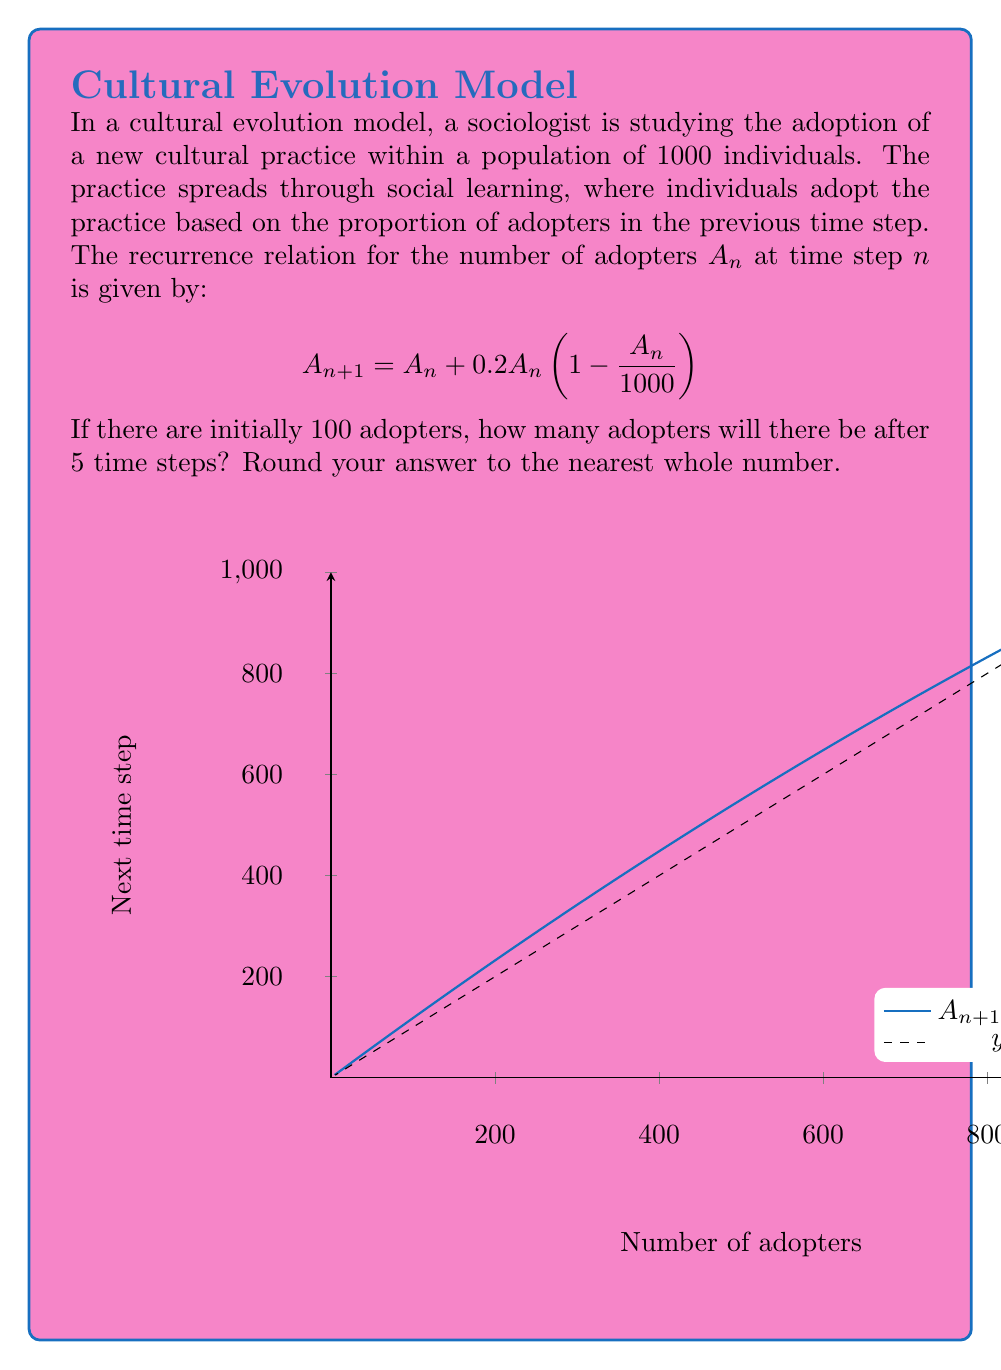Could you help me with this problem? To solve this problem, we need to apply the recurrence relation iteratively for 5 time steps:

1) Initial condition: $A_0 = 100$

2) First time step:
   $A_1 = 100 + 0.2 \cdot 100 \cdot (1 - \frac{100}{1000}) = 100 + 20 \cdot 0.9 = 118$

3) Second time step:
   $A_2 = 118 + 0.2 \cdot 118 \cdot (1 - \frac{118}{1000}) \approx 137.97$

4) Third time step:
   $A_3 = 137.97 + 0.2 \cdot 137.97 \cdot (1 - \frac{137.97}{1000}) \approx 159.78$

5) Fourth time step:
   $A_4 = 159.78 + 0.2 \cdot 159.78 \cdot (1 - \frac{159.78}{1000}) \approx 183.37$

6) Fifth time step:
   $A_5 = 183.37 + 0.2 \cdot 183.37 \cdot (1 - \frac{183.37}{1000}) \approx 208.63$

7) Rounding to the nearest whole number: 209

This model demonstrates a logistic growth pattern, which is common in cultural diffusion processes. The rate of adoption is initially slow, then accelerates, and finally slows down as it approaches saturation.
Answer: 209 